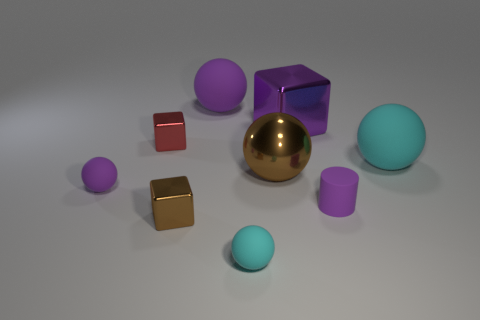There is a brown object right of the large purple matte sphere; how big is it?
Your answer should be very brief. Large. Does the matte cylinder have the same size as the purple block?
Keep it short and to the point. No. What is the color of the other small metallic object that is the same shape as the small red metallic object?
Keep it short and to the point. Brown. What color is the small cube that is in front of the small purple object left of the big metal cube?
Keep it short and to the point. Brown. The red object that is the same shape as the tiny brown metallic thing is what size?
Provide a short and direct response. Small. What number of tiny blue cylinders have the same material as the small cyan sphere?
Give a very brief answer. 0. There is a cyan thing on the left side of the big cyan rubber ball; how many big metallic objects are on the left side of it?
Provide a succinct answer. 0. There is a tiny brown metallic block; are there any purple matte cylinders on the left side of it?
Ensure brevity in your answer.  No. Does the purple thing that is behind the big purple metallic block have the same shape as the small red metal thing?
Give a very brief answer. No. What material is the big sphere that is the same color as the rubber cylinder?
Your answer should be compact. Rubber. 